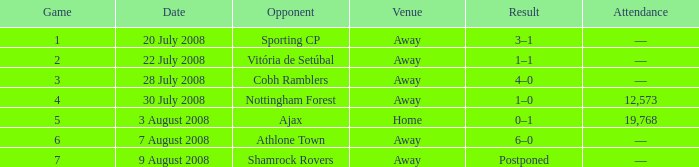What is the cumulative count of games featuring athlone town as the opposition? 1.0. Give me the full table as a dictionary. {'header': ['Game', 'Date', 'Opponent', 'Venue', 'Result', 'Attendance'], 'rows': [['1', '20 July 2008', 'Sporting CP', 'Away', '3–1', '—'], ['2', '22 July 2008', 'Vitória de Setúbal', 'Away', '1–1', '—'], ['3', '28 July 2008', 'Cobh Ramblers', 'Away', '4–0', '—'], ['4', '30 July 2008', 'Nottingham Forest', 'Away', '1–0', '12,573'], ['5', '3 August 2008', 'Ajax', 'Home', '0–1', '19,768'], ['6', '7 August 2008', 'Athlone Town', 'Away', '6–0', '—'], ['7', '9 August 2008', 'Shamrock Rovers', 'Away', 'Postponed', '—']]} 